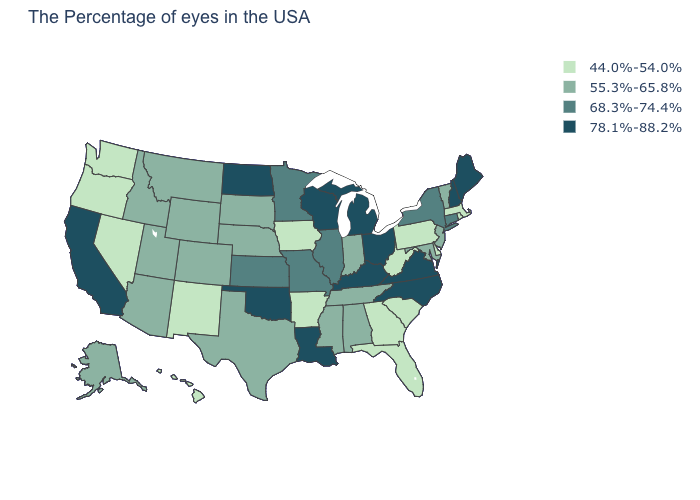Which states have the lowest value in the MidWest?
Answer briefly. Iowa. What is the value of Maine?
Be succinct. 78.1%-88.2%. Among the states that border Pennsylvania , does Ohio have the highest value?
Answer briefly. Yes. Among the states that border Pennsylvania , which have the lowest value?
Keep it brief. Delaware, West Virginia. Name the states that have a value in the range 68.3%-74.4%?
Be succinct. Connecticut, New York, Illinois, Missouri, Minnesota, Kansas. Does Louisiana have the lowest value in the USA?
Give a very brief answer. No. What is the value of Idaho?
Be succinct. 55.3%-65.8%. Which states have the lowest value in the Northeast?
Keep it brief. Massachusetts, Rhode Island, Pennsylvania. Does New York have the highest value in the Northeast?
Give a very brief answer. No. Name the states that have a value in the range 55.3%-65.8%?
Keep it brief. Vermont, New Jersey, Maryland, Indiana, Alabama, Tennessee, Mississippi, Nebraska, Texas, South Dakota, Wyoming, Colorado, Utah, Montana, Arizona, Idaho, Alaska. Among the states that border Colorado , does New Mexico have the lowest value?
Quick response, please. Yes. Which states have the lowest value in the South?
Short answer required. Delaware, South Carolina, West Virginia, Florida, Georgia, Arkansas. Name the states that have a value in the range 55.3%-65.8%?
Short answer required. Vermont, New Jersey, Maryland, Indiana, Alabama, Tennessee, Mississippi, Nebraska, Texas, South Dakota, Wyoming, Colorado, Utah, Montana, Arizona, Idaho, Alaska. Name the states that have a value in the range 44.0%-54.0%?
Write a very short answer. Massachusetts, Rhode Island, Delaware, Pennsylvania, South Carolina, West Virginia, Florida, Georgia, Arkansas, Iowa, New Mexico, Nevada, Washington, Oregon, Hawaii. Among the states that border Alabama , does Tennessee have the highest value?
Keep it brief. Yes. 